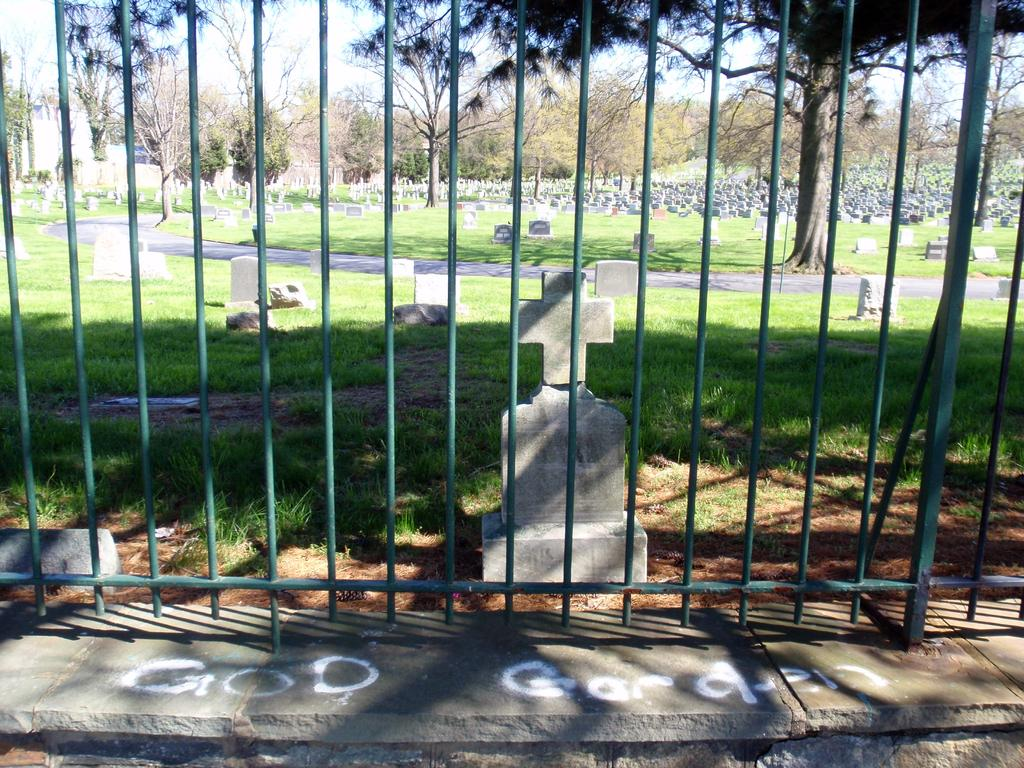What is the main setting of the image? There is a graveyard in the image. What type of vegetation can be seen in the image? There are trees in the image. What can be seen through the iron grills in the image? The sky is visible through the iron grills in the image. What type of self-pleasure is depicted in the image? There is no depiction of self-pleasure in the image; it features a graveyard with trees and a visible sky through iron grills. 